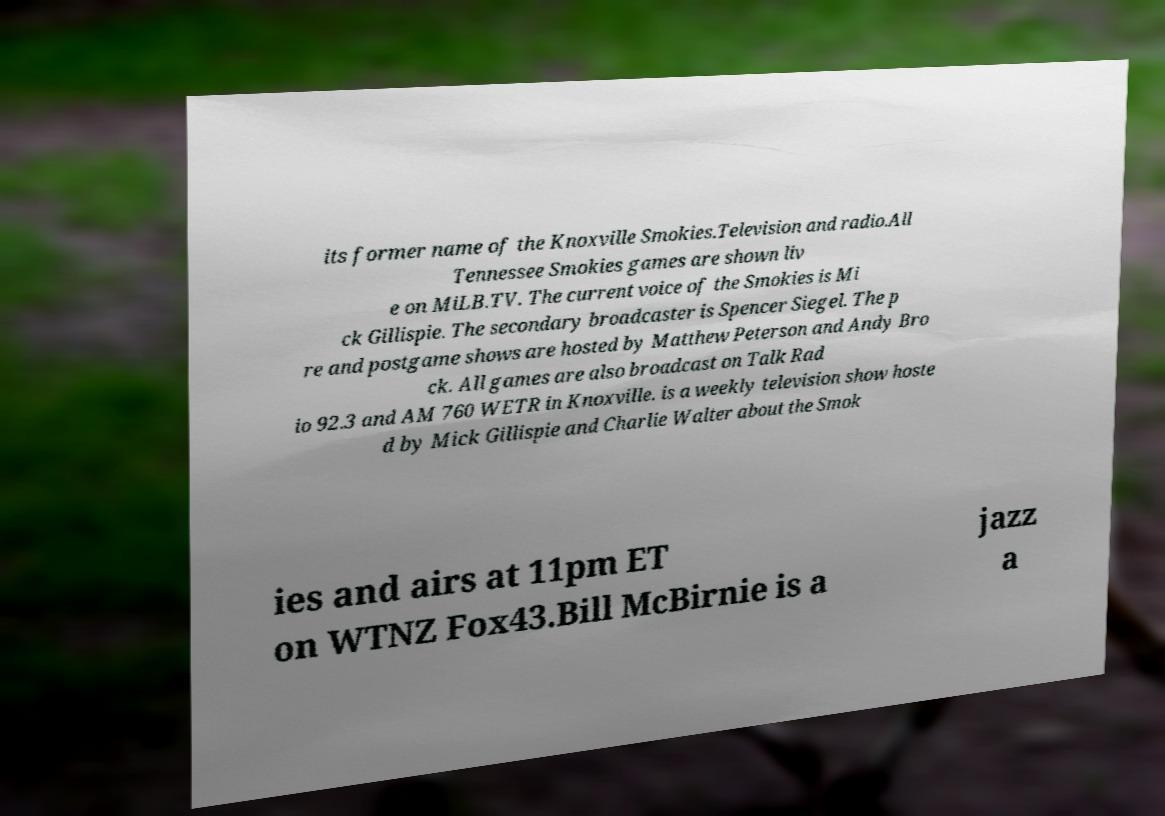Could you assist in decoding the text presented in this image and type it out clearly? its former name of the Knoxville Smokies.Television and radio.All Tennessee Smokies games are shown liv e on MiLB.TV. The current voice of the Smokies is Mi ck Gillispie. The secondary broadcaster is Spencer Siegel. The p re and postgame shows are hosted by Matthew Peterson and Andy Bro ck. All games are also broadcast on Talk Rad io 92.3 and AM 760 WETR in Knoxville. is a weekly television show hoste d by Mick Gillispie and Charlie Walter about the Smok ies and airs at 11pm ET on WTNZ Fox43.Bill McBirnie is a jazz a 